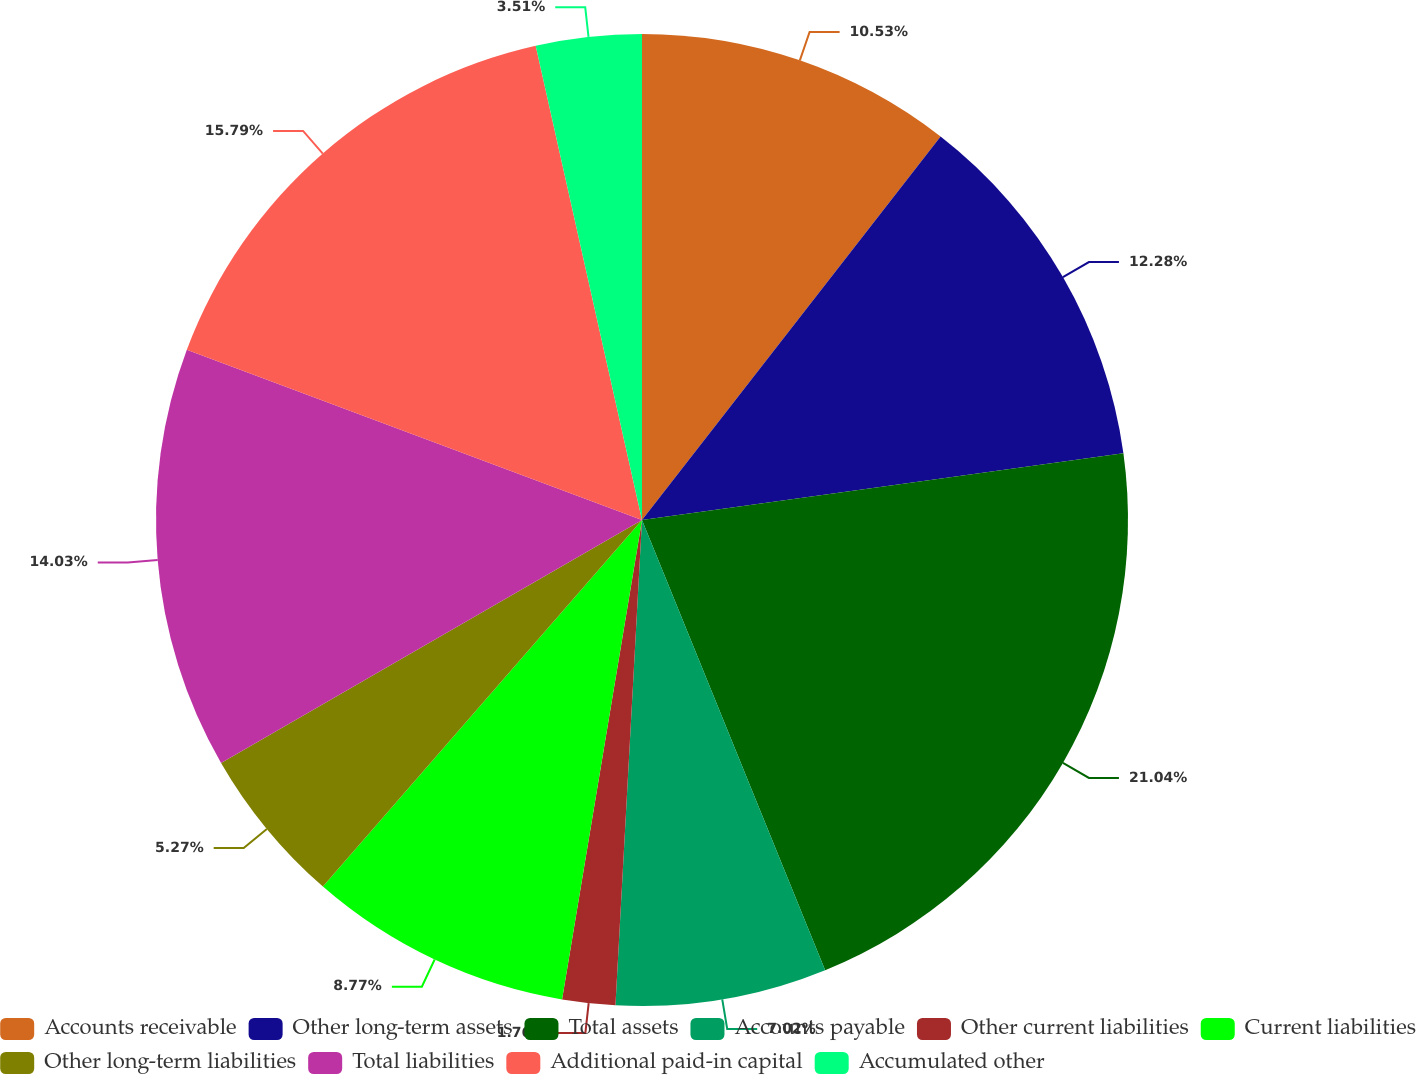Convert chart to OTSL. <chart><loc_0><loc_0><loc_500><loc_500><pie_chart><fcel>Accounts receivable<fcel>Other long-term assets<fcel>Total assets<fcel>Accounts payable<fcel>Other current liabilities<fcel>Current liabilities<fcel>Other long-term liabilities<fcel>Total liabilities<fcel>Additional paid-in capital<fcel>Accumulated other<nl><fcel>10.53%<fcel>12.28%<fcel>21.04%<fcel>7.02%<fcel>1.76%<fcel>8.77%<fcel>5.27%<fcel>14.03%<fcel>15.79%<fcel>3.51%<nl></chart> 